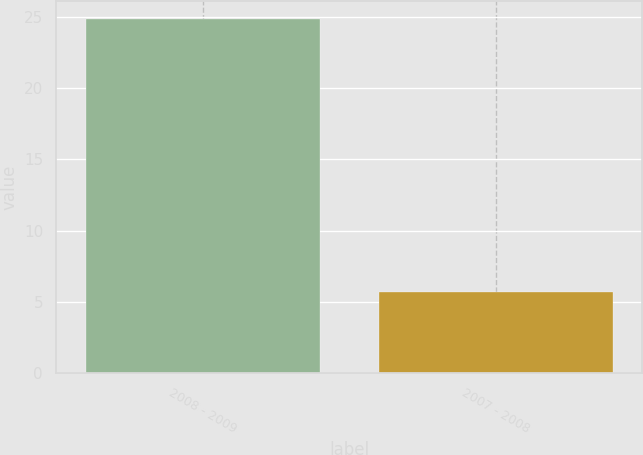Convert chart. <chart><loc_0><loc_0><loc_500><loc_500><bar_chart><fcel>2008 - 2009<fcel>2007 - 2008<nl><fcel>24.9<fcel>5.7<nl></chart> 